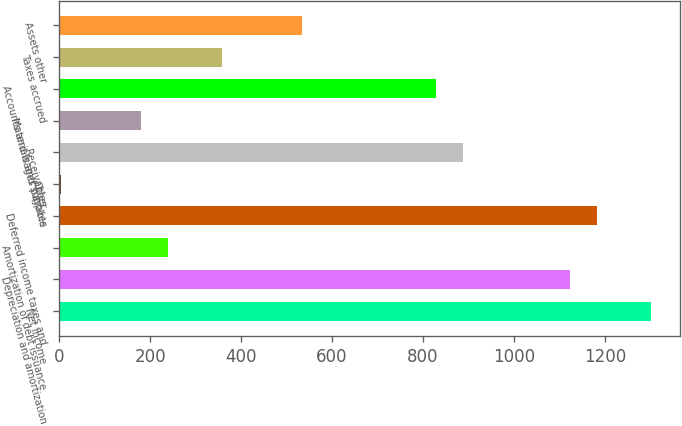Convert chart to OTSL. <chart><loc_0><loc_0><loc_500><loc_500><bar_chart><fcel>Net income<fcel>Depreciation and amortization<fcel>Amortization of debt issuance<fcel>Deferred income taxes and<fcel>Other<fcel>Receivables<fcel>Materials and supplies<fcel>Accounts and wages payable<fcel>Taxes accrued<fcel>Assets other<nl><fcel>1301<fcel>1124<fcel>239<fcel>1183<fcel>3<fcel>888<fcel>180<fcel>829<fcel>357<fcel>534<nl></chart> 